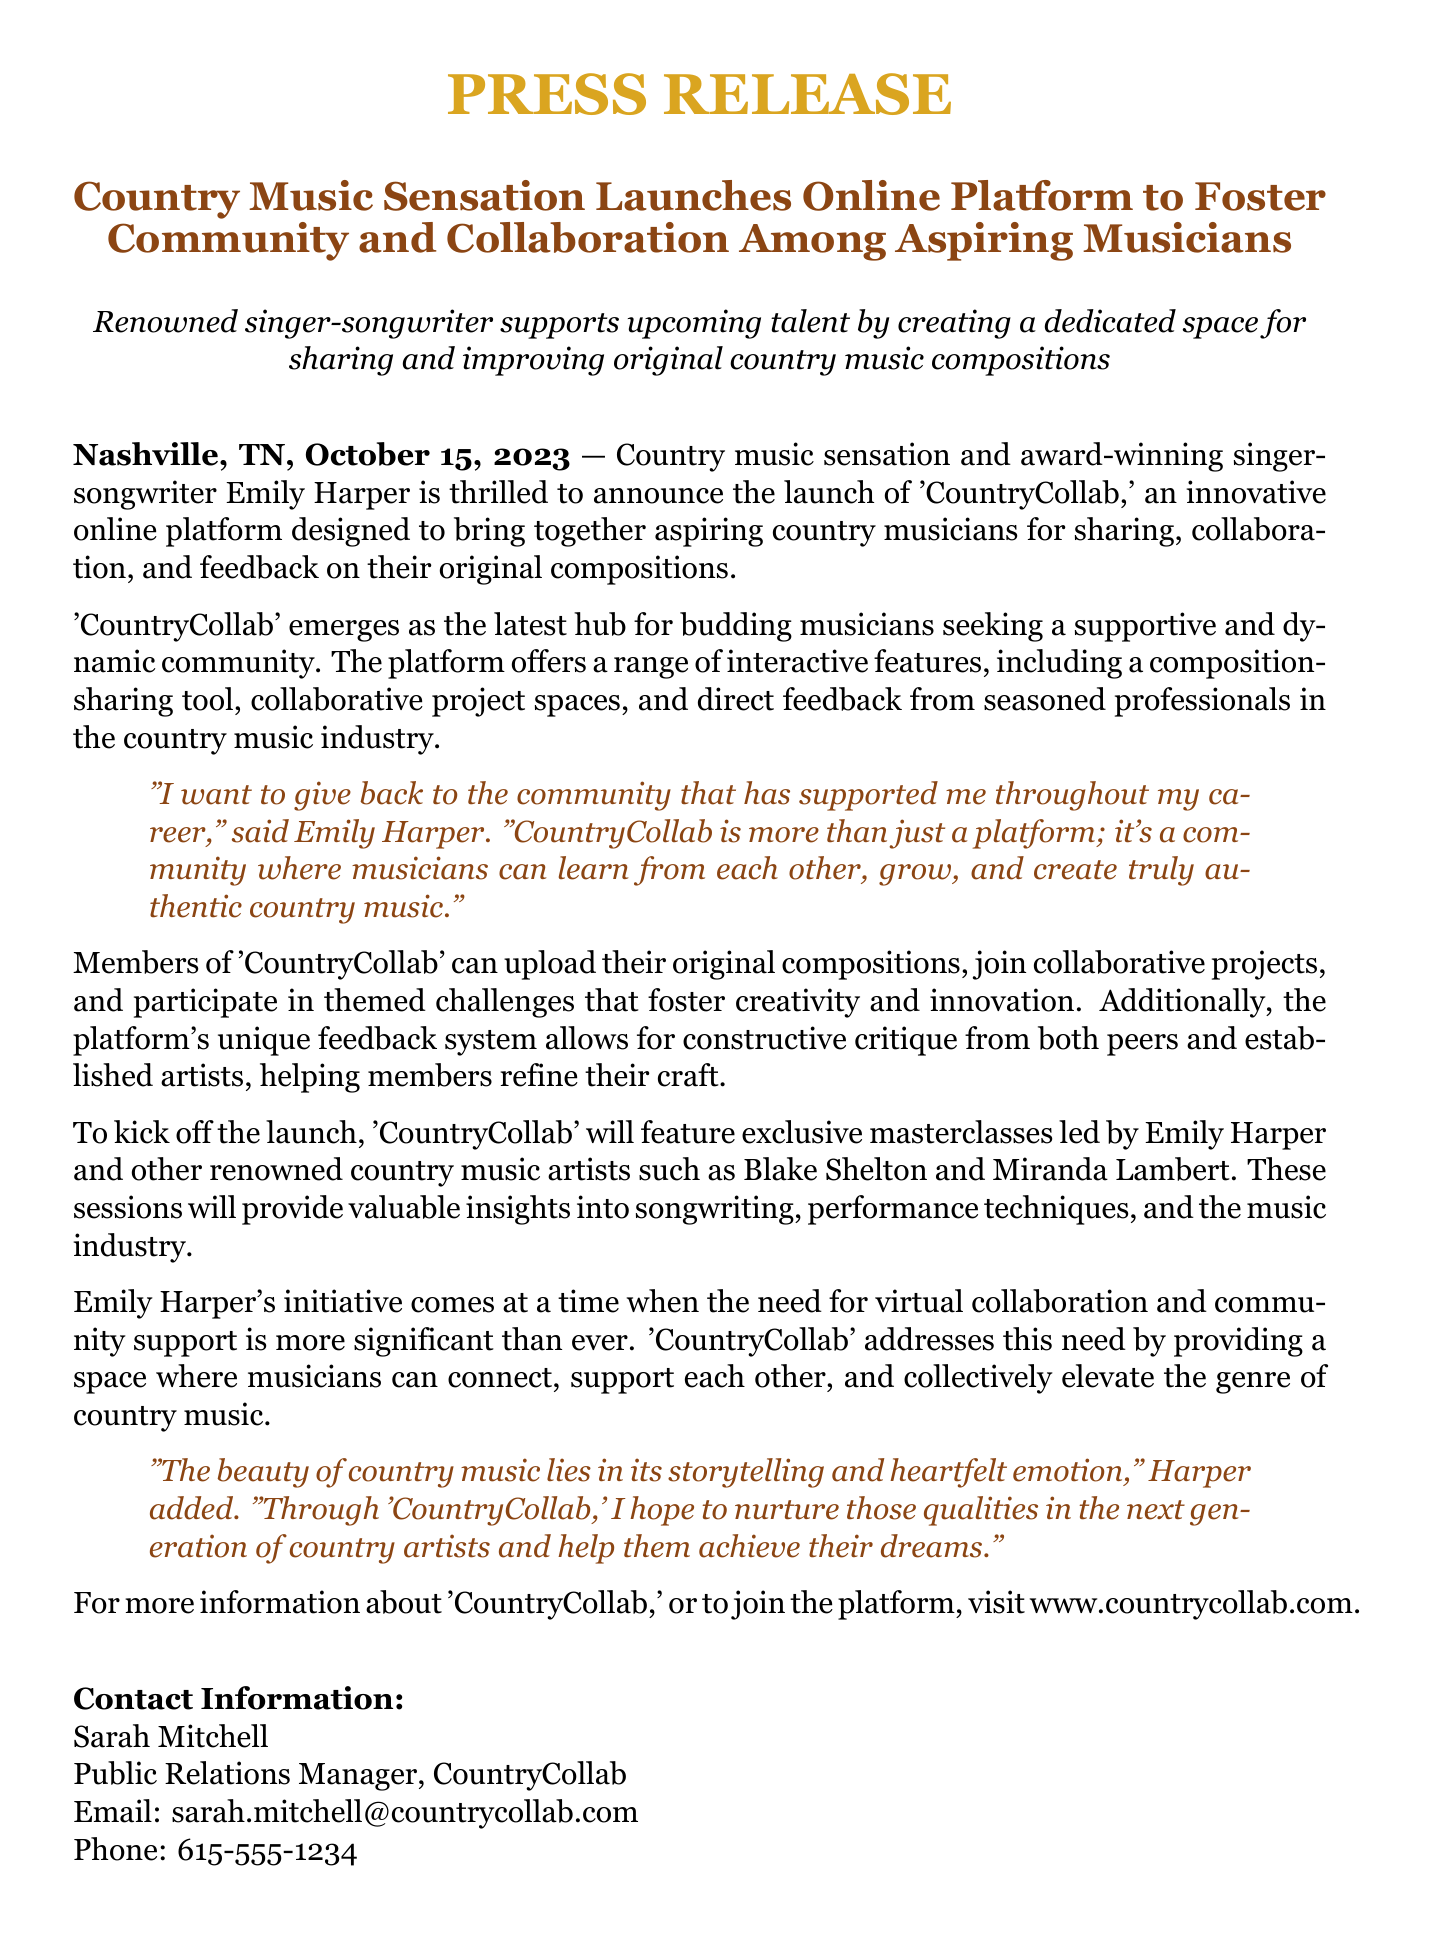What is the name of the online platform launched by Emily Harper? The document states that the online platform is called 'CountryCollab.'
Answer: 'CountryCollab' When was the press release issued? The press release states that it was issued on October 15, 2023.
Answer: October 15, 2023 Who are the renowned country music artists featured in the masterclasses? The document mentions Blake Shelton and Miranda Lambert as featured artists.
Answer: Blake Shelton and Miranda Lambert What is the primary goal of 'CountryCollab'? The document indicates that the goal is to foster community and collaboration among aspiring country musicians.
Answer: Foster community and collaboration What type of system does 'CountryCollab' include for feedback? The document describes a unique feedback system for constructive critique.
Answer: Constructive critique Why does Emily Harper want to support aspiring musicians? The document quotes Harper saying she wants to give back to the community that has supported her throughout her career.
Answer: Give back to the community What features does 'CountryCollab' offer its members? The document lists features including a composition-sharing tool and collaborative project spaces.
Answer: Composition-sharing tool, collaborative project spaces In what genre is 'CountryCollab' focused? The document clearly states that 'CountryCollab' is focused on country music.
Answer: Country music What is the role of Sarah Mitchell in relation to 'CountryCollab'? The document identifies Sarah Mitchell as the Public Relations Manager.
Answer: Public Relations Manager 